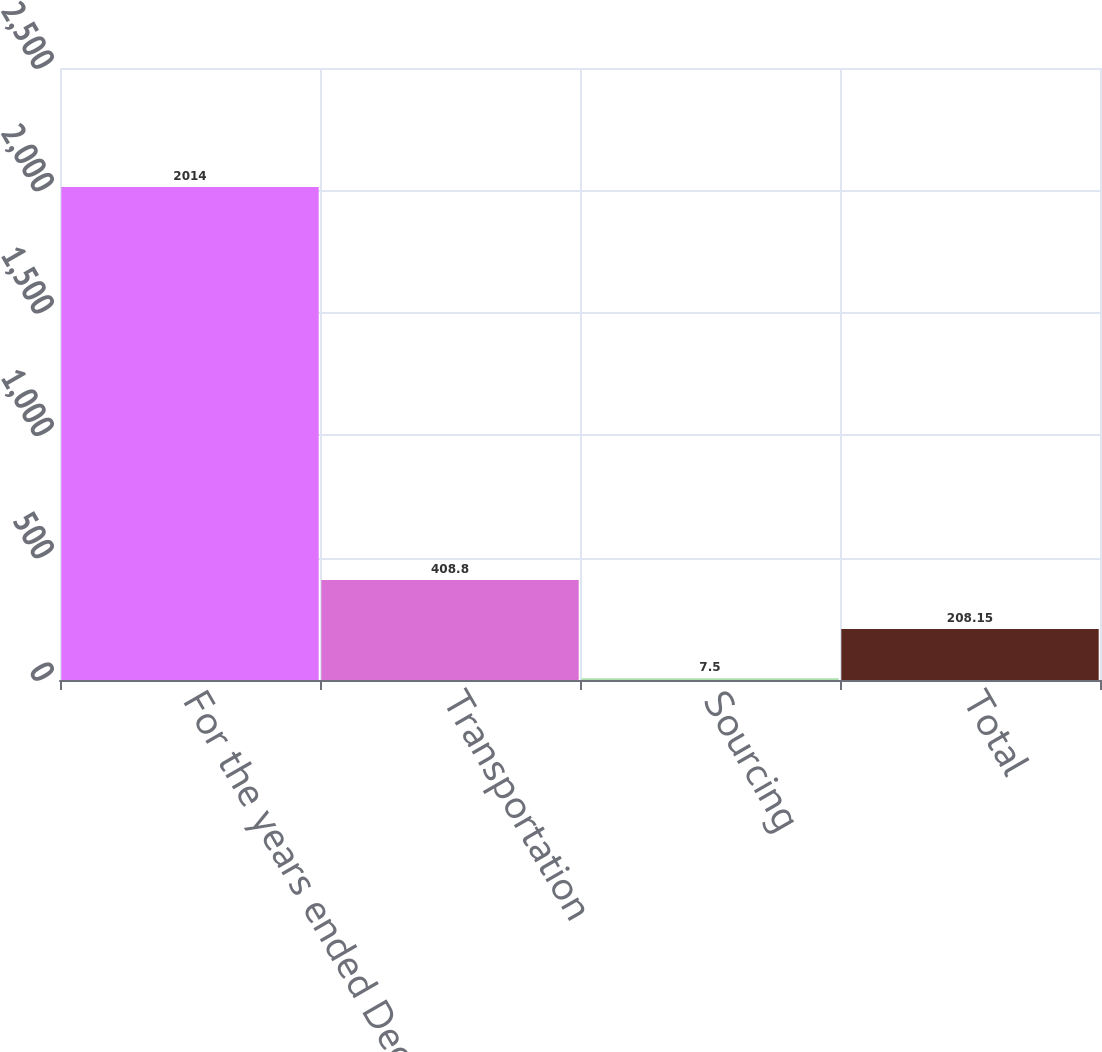<chart> <loc_0><loc_0><loc_500><loc_500><bar_chart><fcel>For the years ended December<fcel>Transportation<fcel>Sourcing<fcel>Total<nl><fcel>2014<fcel>408.8<fcel>7.5<fcel>208.15<nl></chart> 